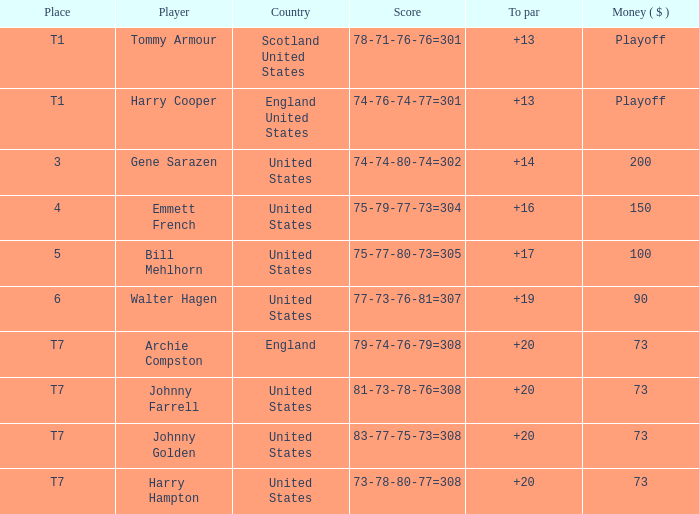What country features a to par less than 19 with a combined score of 75-79-77-73=304? United States. 